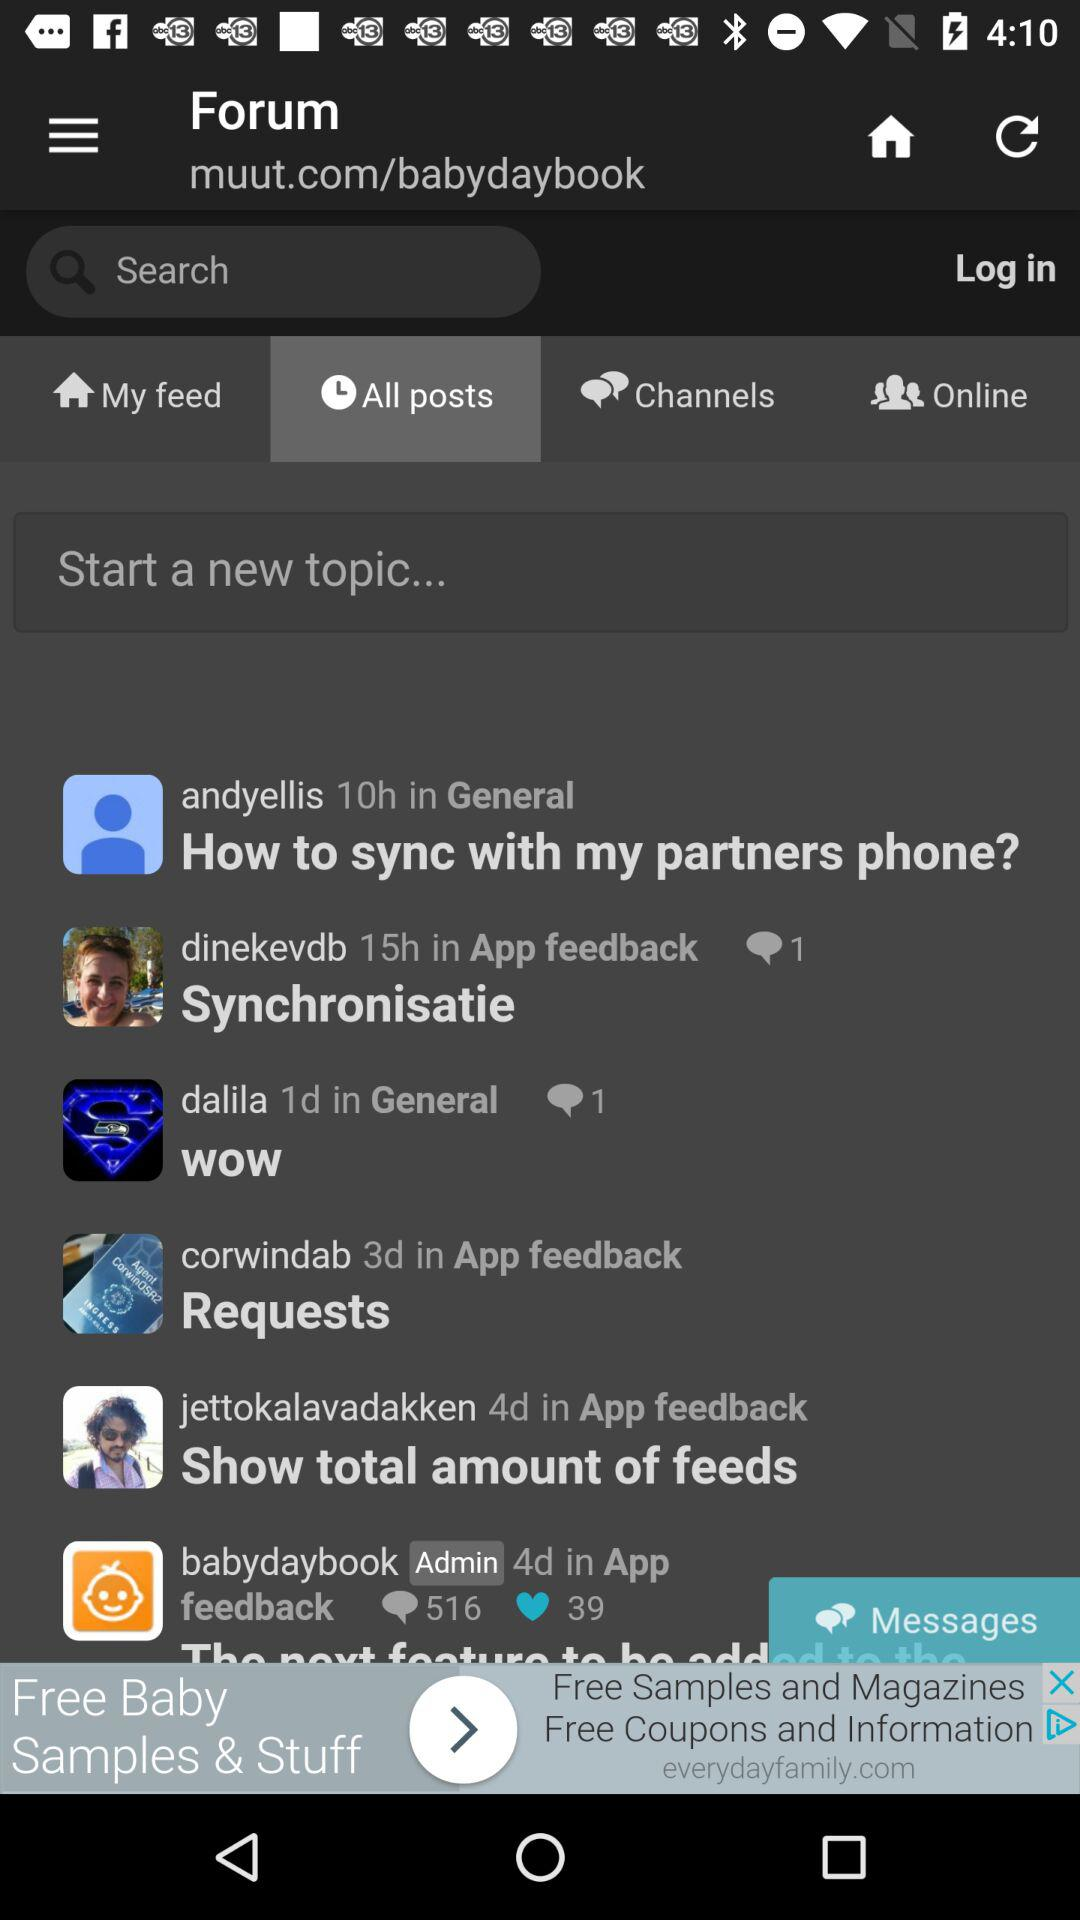How many comments are there on Dalila's post? There is 1 comment on Dalila's post. 